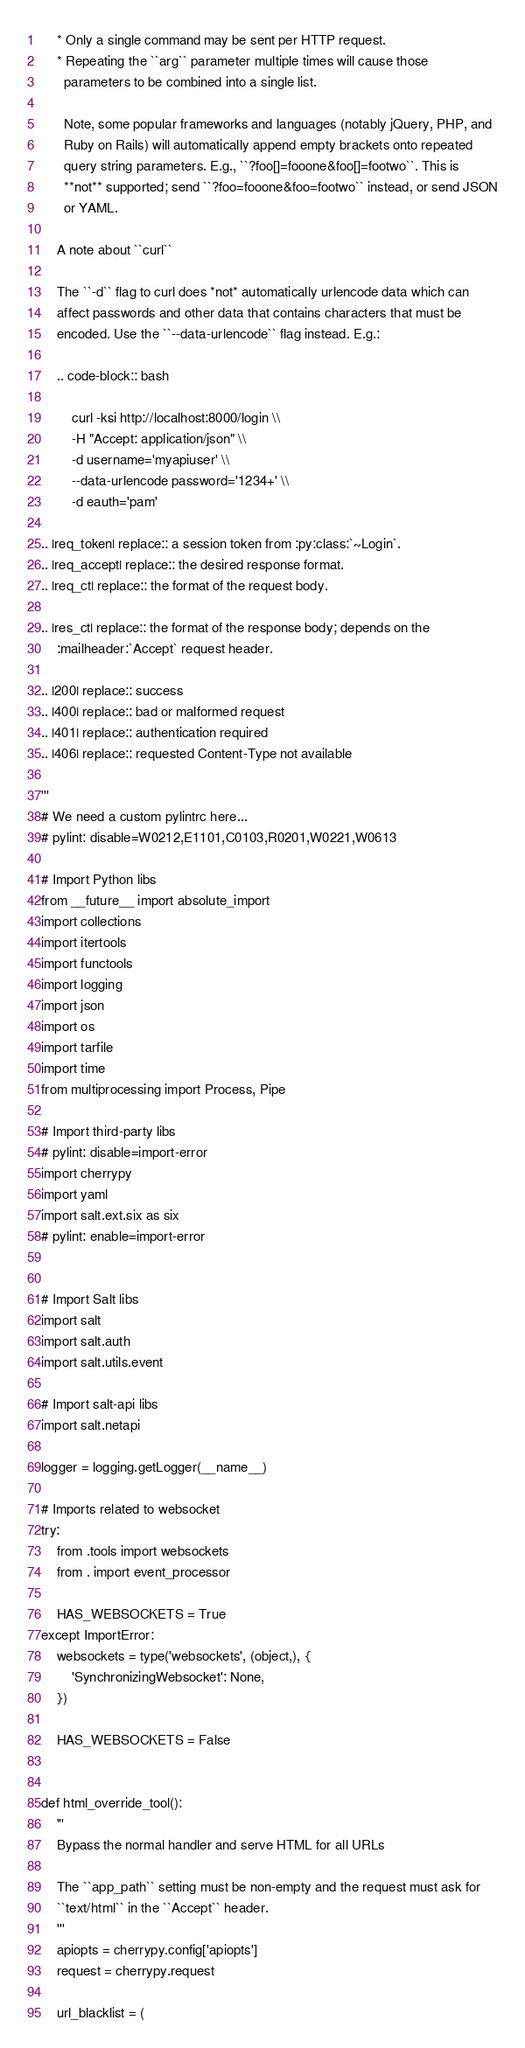Convert code to text. <code><loc_0><loc_0><loc_500><loc_500><_Python_>    * Only a single command may be sent per HTTP request.
    * Repeating the ``arg`` parameter multiple times will cause those
      parameters to be combined into a single list.

      Note, some popular frameworks and languages (notably jQuery, PHP, and
      Ruby on Rails) will automatically append empty brackets onto repeated
      query string parameters. E.g., ``?foo[]=fooone&foo[]=footwo``. This is
      **not** supported; send ``?foo=fooone&foo=footwo`` instead, or send JSON
      or YAML.

    A note about ``curl``

    The ``-d`` flag to curl does *not* automatically urlencode data which can
    affect passwords and other data that contains characters that must be
    encoded. Use the ``--data-urlencode`` flag instead. E.g.:

    .. code-block:: bash

        curl -ksi http://localhost:8000/login \\
        -H "Accept: application/json" \\
        -d username='myapiuser' \\
        --data-urlencode password='1234+' \\
        -d eauth='pam'

.. |req_token| replace:: a session token from :py:class:`~Login`.
.. |req_accept| replace:: the desired response format.
.. |req_ct| replace:: the format of the request body.

.. |res_ct| replace:: the format of the response body; depends on the
    :mailheader:`Accept` request header.

.. |200| replace:: success
.. |400| replace:: bad or malformed request
.. |401| replace:: authentication required
.. |406| replace:: requested Content-Type not available

'''
# We need a custom pylintrc here...
# pylint: disable=W0212,E1101,C0103,R0201,W0221,W0613

# Import Python libs
from __future__ import absolute_import
import collections
import itertools
import functools
import logging
import json
import os
import tarfile
import time
from multiprocessing import Process, Pipe

# Import third-party libs
# pylint: disable=import-error
import cherrypy
import yaml
import salt.ext.six as six
# pylint: enable=import-error


# Import Salt libs
import salt
import salt.auth
import salt.utils.event

# Import salt-api libs
import salt.netapi

logger = logging.getLogger(__name__)

# Imports related to websocket
try:
    from .tools import websockets
    from . import event_processor

    HAS_WEBSOCKETS = True
except ImportError:
    websockets = type('websockets', (object,), {
        'SynchronizingWebsocket': None,
    })

    HAS_WEBSOCKETS = False


def html_override_tool():
    '''
    Bypass the normal handler and serve HTML for all URLs

    The ``app_path`` setting must be non-empty and the request must ask for
    ``text/html`` in the ``Accept`` header.
    '''
    apiopts = cherrypy.config['apiopts']
    request = cherrypy.request

    url_blacklist = (</code> 